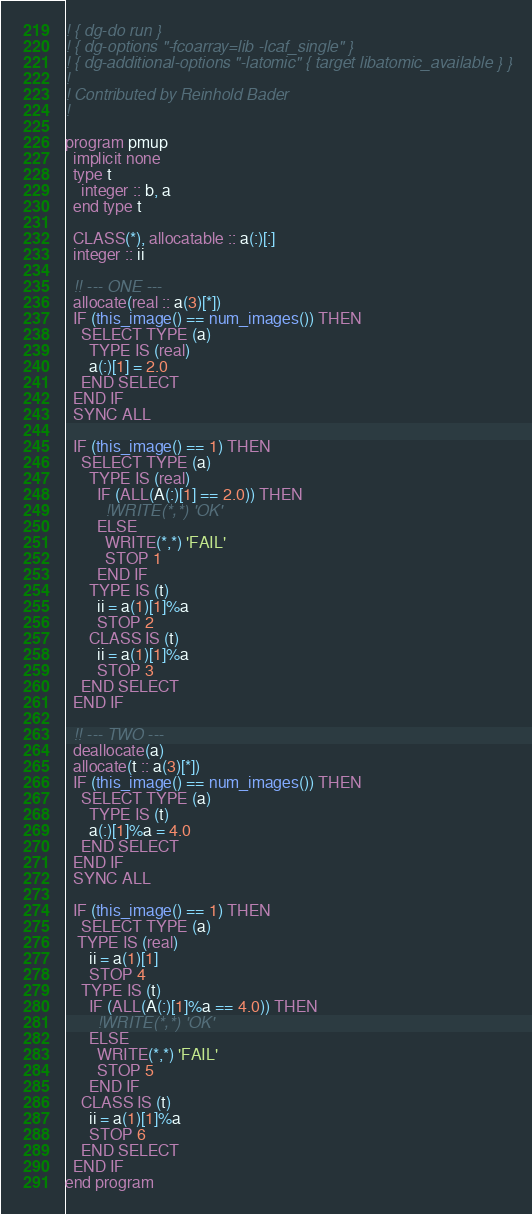Convert code to text. <code><loc_0><loc_0><loc_500><loc_500><_FORTRAN_>! { dg-do run }
! { dg-options "-fcoarray=lib -lcaf_single" }
! { dg-additional-options "-latomic" { target libatomic_available } }
!
! Contributed by Reinhold Bader
!

program pmup
  implicit none
  type t
    integer :: b, a
  end type t

  CLASS(*), allocatable :: a(:)[:]
  integer :: ii

  !! --- ONE --- 
  allocate(real :: a(3)[*])
  IF (this_image() == num_images()) THEN
    SELECT TYPE (a)
      TYPE IS (real)
      a(:)[1] = 2.0
    END SELECT
  END IF
  SYNC ALL

  IF (this_image() == 1) THEN
    SELECT TYPE (a)
      TYPE IS (real)
        IF (ALL(A(:)[1] == 2.0)) THEN
          !WRITE(*,*) 'OK'
        ELSE
          WRITE(*,*) 'FAIL'
          STOP 1
        END IF
      TYPE IS (t)
        ii = a(1)[1]%a
        STOP 2
      CLASS IS (t)
        ii = a(1)[1]%a
        STOP 3
    END SELECT
  END IF

  !! --- TWO --- 
  deallocate(a)
  allocate(t :: a(3)[*])
  IF (this_image() == num_images()) THEN
    SELECT TYPE (a)
      TYPE IS (t)
      a(:)[1]%a = 4.0
    END SELECT
  END IF
  SYNC ALL

  IF (this_image() == 1) THEN
    SELECT TYPE (a)
   TYPE IS (real)
      ii = a(1)[1]
      STOP 4
    TYPE IS (t)
      IF (ALL(A(:)[1]%a == 4.0)) THEN
        !WRITE(*,*) 'OK'
      ELSE
        WRITE(*,*) 'FAIL'
        STOP 5
      END IF
    CLASS IS (t)
      ii = a(1)[1]%a
      STOP 6
    END SELECT
  END IF
end program
</code> 